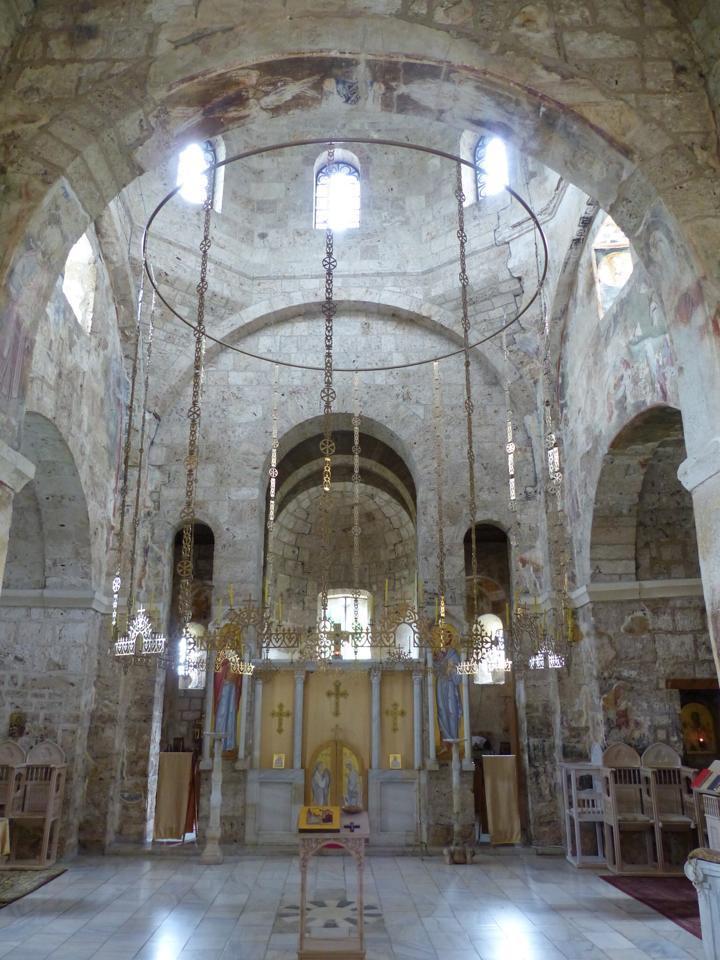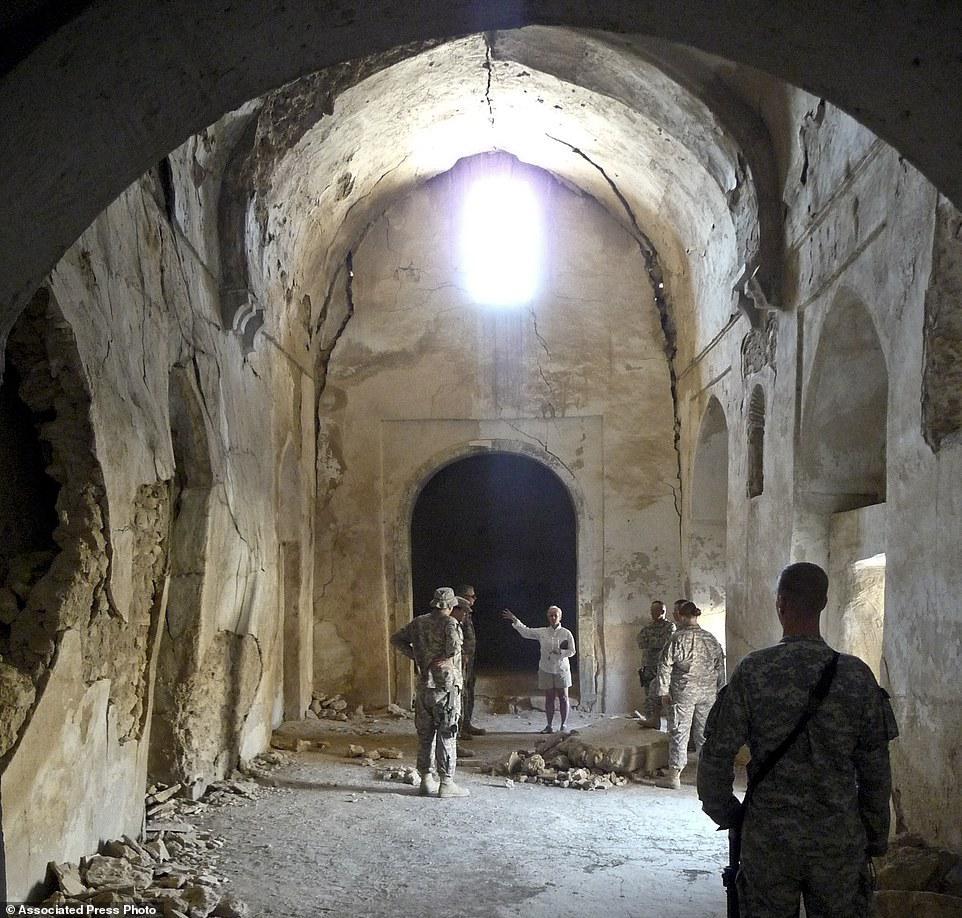The first image is the image on the left, the second image is the image on the right. Assess this claim about the two images: "In one image, an ornate arched entry with columns and a colored painting under the arch is set in an outside stone wall of a building.". Correct or not? Answer yes or no. No. The first image is the image on the left, the second image is the image on the right. Considering the images on both sides, is "Multiple people stand in front of an arch in one image." valid? Answer yes or no. Yes. 